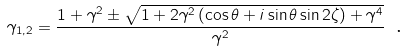<formula> <loc_0><loc_0><loc_500><loc_500>\gamma _ { 1 , 2 } = \frac { 1 + \gamma ^ { 2 } \pm \sqrt { 1 + 2 \gamma ^ { 2 } \left ( \cos \theta + i \sin \theta \sin 2 \zeta \right ) + \gamma ^ { 4 } } } { \gamma ^ { 2 } } \text { .}</formula> 